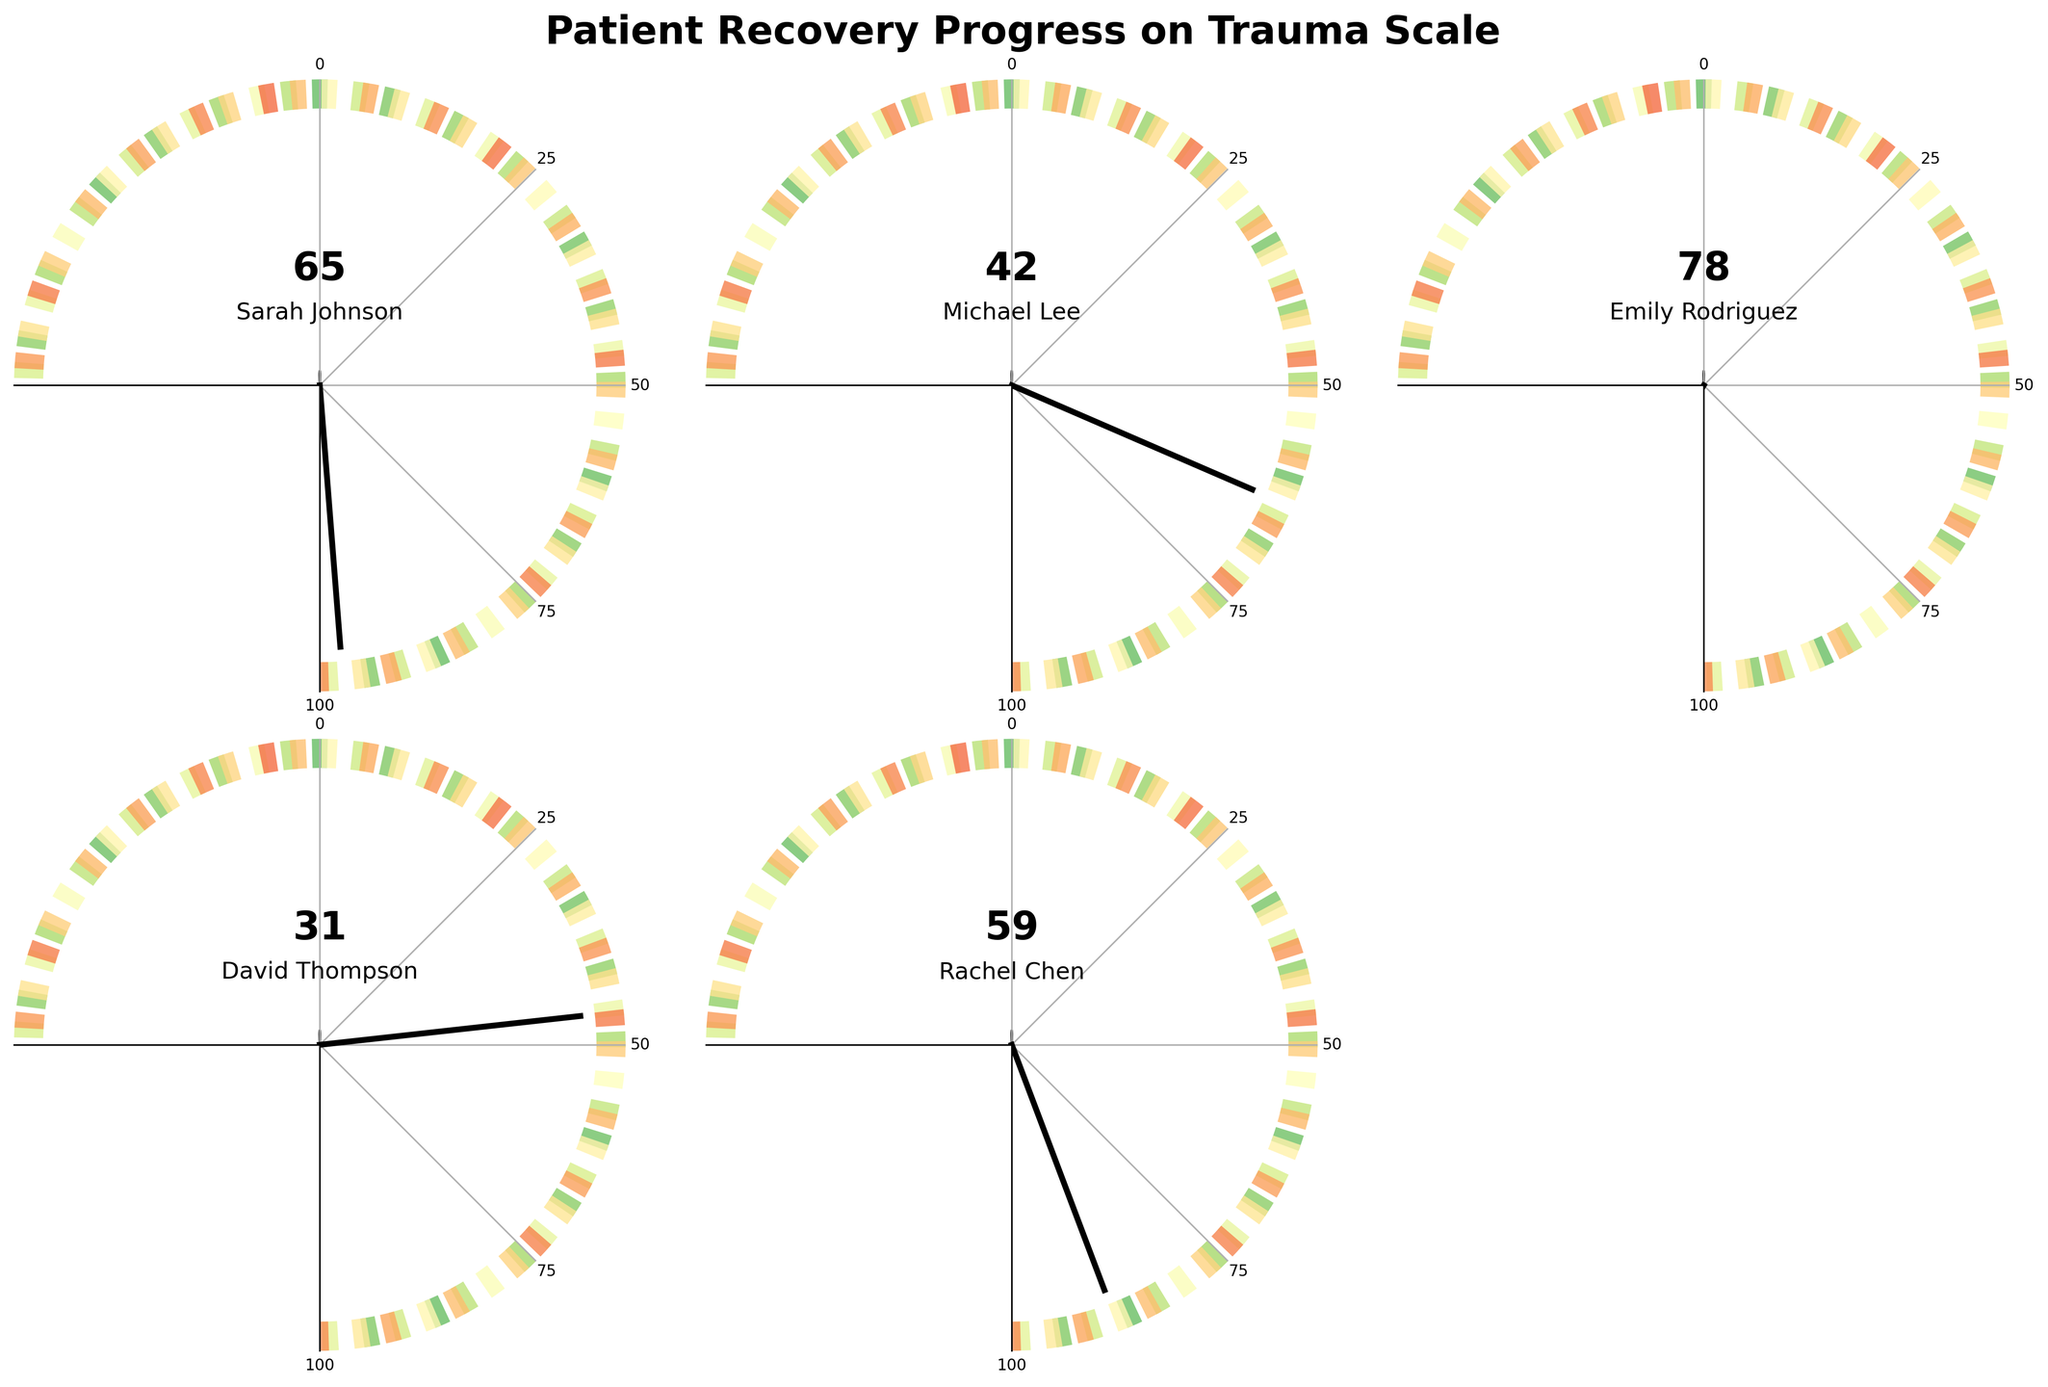What is the trauma scale score for Emily Rodriguez? The figure shows individual gauge charts for each patient with their trauma scale score. Emily Rodriguez's gauge points to 78.
Answer: 78 What is the title of the figure? The title is written at the top in a bold font. It says 'Patient Recovery Progress on Trauma Scale'.
Answer: Patient Recovery Progress on Trauma Scale Which patient has the lowest trauma scale score? The gauge for David Thompson shows the needle pointing to the lowest value among all patients, which is 31.
Answer: David Thompson What is the difference between the highest and lowest trauma scale scores? The highest score is Emily Rodriguez with 78, and the lowest is David Thompson with 31. The difference is calculated by subtracting 31 from 78.
Answer: 47 What are the trauma scale scores for Sarah Johnson and Rachel Chen? The gauge charts for Sarah Johnson and Rachel Chen show scores of 65 and 59, respectively.
Answer: 65 and 59 Which patient scores higher on the trauma scale: Michael Lee or Rachel Chen? Comparing the gauge charts, Michael Lee's score is 42, and Rachel Chen's score is 59. Rachel Chen scores higher.
Answer: Rachel Chen What is the average trauma scale score of all the patients? The scores are 65, 42, 78, 31, and 59. Adding these gives 275, and dividing by 5 gives the average.
Answer: 55 Among all patients, how many have a score above 50? By looking at the gauge charts, Sarah Johnson (65), Emily Rodriguez (78), and Rachel Chen (59) have scores above 50, making it 3 patients.
Answer: 3 Which patient is closest to the midpoint value of the trauma scale (i.e., 50)? Comparing scores to 50, Rachel Chen's score of 59 is closest to 50.
Answer: Rachel Chen By looking at the colors, how would you interpret the gauge value areas in terms of recovery progress? The gauge colors have a gradient from red to green. Red likely represents higher trauma and green lower trauma, indicating better recovery as the score lowers.
Answer: Green indicates better recovery, red indicates higher trauma 